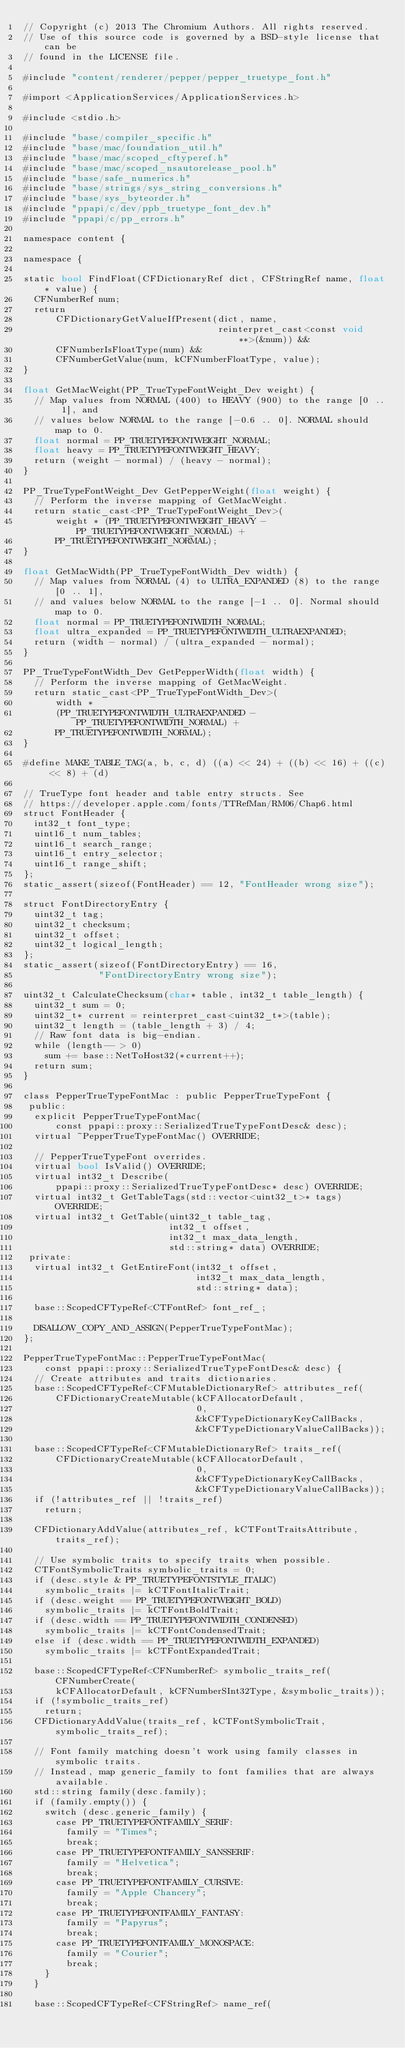Convert code to text. <code><loc_0><loc_0><loc_500><loc_500><_ObjectiveC_>// Copyright (c) 2013 The Chromium Authors. All rights reserved.
// Use of this source code is governed by a BSD-style license that can be
// found in the LICENSE file.

#include "content/renderer/pepper/pepper_truetype_font.h"

#import <ApplicationServices/ApplicationServices.h>

#include <stdio.h>

#include "base/compiler_specific.h"
#include "base/mac/foundation_util.h"
#include "base/mac/scoped_cftyperef.h"
#include "base/mac/scoped_nsautorelease_pool.h"
#include "base/safe_numerics.h"
#include "base/strings/sys_string_conversions.h"
#include "base/sys_byteorder.h"
#include "ppapi/c/dev/ppb_truetype_font_dev.h"
#include "ppapi/c/pp_errors.h"

namespace content {

namespace {

static bool FindFloat(CFDictionaryRef dict, CFStringRef name, float* value) {
  CFNumberRef num;
  return
      CFDictionaryGetValueIfPresent(dict, name,
                                    reinterpret_cast<const void**>(&num)) &&
      CFNumberIsFloatType(num) &&
      CFNumberGetValue(num, kCFNumberFloatType, value);
}

float GetMacWeight(PP_TrueTypeFontWeight_Dev weight) {
  // Map values from NORMAL (400) to HEAVY (900) to the range [0 .. 1], and
  // values below NORMAL to the range [-0.6 .. 0]. NORMAL should map to 0.
  float normal = PP_TRUETYPEFONTWEIGHT_NORMAL;
  float heavy = PP_TRUETYPEFONTWEIGHT_HEAVY;
  return (weight - normal) / (heavy - normal);
}

PP_TrueTypeFontWeight_Dev GetPepperWeight(float weight) {
  // Perform the inverse mapping of GetMacWeight.
  return static_cast<PP_TrueTypeFontWeight_Dev>(
      weight * (PP_TRUETYPEFONTWEIGHT_HEAVY - PP_TRUETYPEFONTWEIGHT_NORMAL) +
      PP_TRUETYPEFONTWEIGHT_NORMAL);
}

float GetMacWidth(PP_TrueTypeFontWidth_Dev width) {
  // Map values from NORMAL (4) to ULTRA_EXPANDED (8) to the range [0 .. 1],
  // and values below NORMAL to the range [-1 .. 0]. Normal should map to 0.
  float normal = PP_TRUETYPEFONTWIDTH_NORMAL;
  float ultra_expanded = PP_TRUETYPEFONTWIDTH_ULTRAEXPANDED;
  return (width - normal) / (ultra_expanded - normal);
}

PP_TrueTypeFontWidth_Dev GetPepperWidth(float width) {
  // Perform the inverse mapping of GetMacWeight.
  return static_cast<PP_TrueTypeFontWidth_Dev>(
      width *
      (PP_TRUETYPEFONTWIDTH_ULTRAEXPANDED - PP_TRUETYPEFONTWIDTH_NORMAL) +
      PP_TRUETYPEFONTWIDTH_NORMAL);
}

#define MAKE_TABLE_TAG(a, b, c, d) ((a) << 24) + ((b) << 16) + ((c) << 8) + (d)

// TrueType font header and table entry structs. See
// https://developer.apple.com/fonts/TTRefMan/RM06/Chap6.html
struct FontHeader {
  int32_t font_type;
  uint16_t num_tables;
  uint16_t search_range;
  uint16_t entry_selector;
  uint16_t range_shift;
};
static_assert(sizeof(FontHeader) == 12, "FontHeader wrong size");

struct FontDirectoryEntry {
  uint32_t tag;
  uint32_t checksum;
  uint32_t offset;
  uint32_t logical_length;
};
static_assert(sizeof(FontDirectoryEntry) == 16,
              "FontDirectoryEntry wrong size");

uint32_t CalculateChecksum(char* table, int32_t table_length) {
  uint32_t sum = 0;
  uint32_t* current = reinterpret_cast<uint32_t*>(table);
  uint32_t length = (table_length + 3) / 4;
  // Raw font data is big-endian.
  while (length-- > 0)
    sum += base::NetToHost32(*current++);
  return sum;
}

class PepperTrueTypeFontMac : public PepperTrueTypeFont {
 public:
  explicit PepperTrueTypeFontMac(
      const ppapi::proxy::SerializedTrueTypeFontDesc& desc);
  virtual ~PepperTrueTypeFontMac() OVERRIDE;

  // PepperTrueTypeFont overrides.
  virtual bool IsValid() OVERRIDE;
  virtual int32_t Describe(
      ppapi::proxy::SerializedTrueTypeFontDesc* desc) OVERRIDE;
  virtual int32_t GetTableTags(std::vector<uint32_t>* tags) OVERRIDE;
  virtual int32_t GetTable(uint32_t table_tag,
                           int32_t offset,
                           int32_t max_data_length,
                           std::string* data) OVERRIDE;
 private:
  virtual int32_t GetEntireFont(int32_t offset,
                                int32_t max_data_length,
                                std::string* data);

  base::ScopedCFTypeRef<CTFontRef> font_ref_;

  DISALLOW_COPY_AND_ASSIGN(PepperTrueTypeFontMac);
};

PepperTrueTypeFontMac::PepperTrueTypeFontMac(
    const ppapi::proxy::SerializedTrueTypeFontDesc& desc) {
  // Create attributes and traits dictionaries.
  base::ScopedCFTypeRef<CFMutableDictionaryRef> attributes_ref(
      CFDictionaryCreateMutable(kCFAllocatorDefault,
                                0,
                                &kCFTypeDictionaryKeyCallBacks,
                                &kCFTypeDictionaryValueCallBacks));

  base::ScopedCFTypeRef<CFMutableDictionaryRef> traits_ref(
      CFDictionaryCreateMutable(kCFAllocatorDefault,
                                0,
                                &kCFTypeDictionaryKeyCallBacks,
                                &kCFTypeDictionaryValueCallBacks));
  if (!attributes_ref || !traits_ref)
    return;

  CFDictionaryAddValue(attributes_ref, kCTFontTraitsAttribute, traits_ref);

  // Use symbolic traits to specify traits when possible.
  CTFontSymbolicTraits symbolic_traits = 0;
  if (desc.style & PP_TRUETYPEFONTSTYLE_ITALIC)
    symbolic_traits |= kCTFontItalicTrait;
  if (desc.weight == PP_TRUETYPEFONTWEIGHT_BOLD)
    symbolic_traits |= kCTFontBoldTrait;
  if (desc.width == PP_TRUETYPEFONTWIDTH_CONDENSED)
    symbolic_traits |= kCTFontCondensedTrait;
  else if (desc.width == PP_TRUETYPEFONTWIDTH_EXPANDED)
    symbolic_traits |= kCTFontExpandedTrait;

  base::ScopedCFTypeRef<CFNumberRef> symbolic_traits_ref(CFNumberCreate(
      kCFAllocatorDefault, kCFNumberSInt32Type, &symbolic_traits));
  if (!symbolic_traits_ref)
    return;
  CFDictionaryAddValue(traits_ref, kCTFontSymbolicTrait, symbolic_traits_ref);

  // Font family matching doesn't work using family classes in symbolic traits.
  // Instead, map generic_family to font families that are always available.
  std::string family(desc.family);
  if (family.empty()) {
    switch (desc.generic_family) {
      case PP_TRUETYPEFONTFAMILY_SERIF:
        family = "Times";
        break;
      case PP_TRUETYPEFONTFAMILY_SANSSERIF:
        family = "Helvetica";
        break;
      case PP_TRUETYPEFONTFAMILY_CURSIVE:
        family = "Apple Chancery";
        break;
      case PP_TRUETYPEFONTFAMILY_FANTASY:
        family = "Papyrus";
        break;
      case PP_TRUETYPEFONTFAMILY_MONOSPACE:
        family = "Courier";
        break;
    }
  }

  base::ScopedCFTypeRef<CFStringRef> name_ref(</code> 